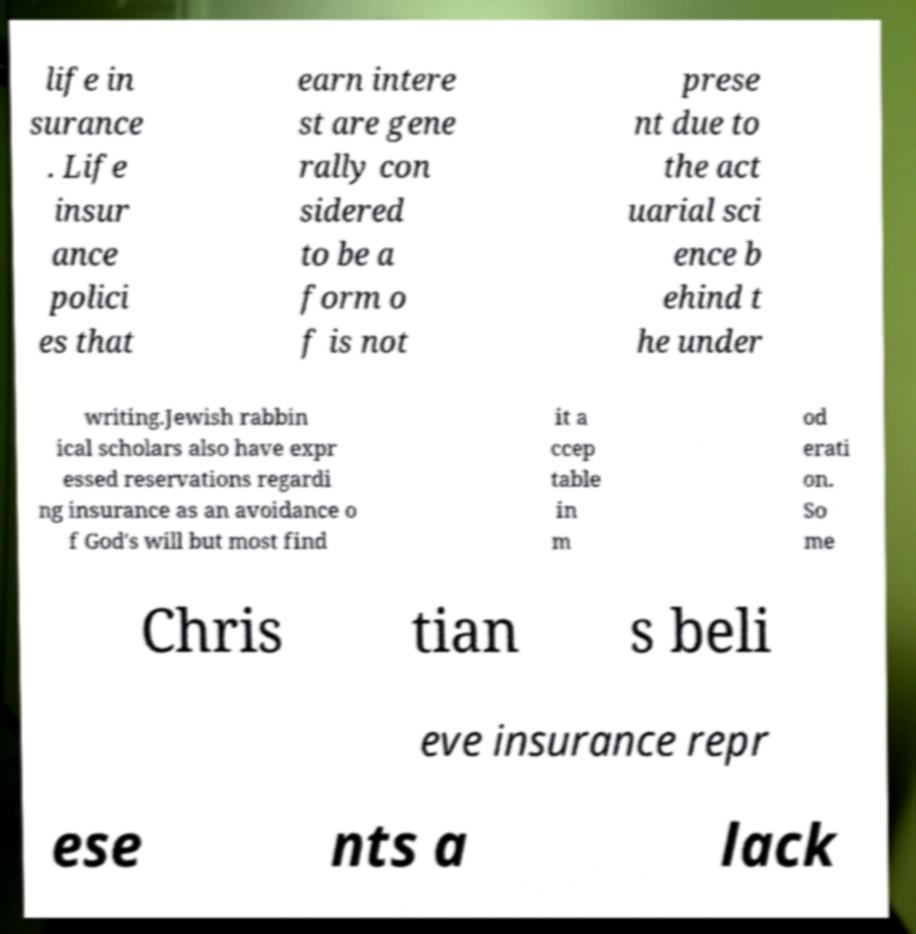Could you extract and type out the text from this image? life in surance . Life insur ance polici es that earn intere st are gene rally con sidered to be a form o f is not prese nt due to the act uarial sci ence b ehind t he under writing.Jewish rabbin ical scholars also have expr essed reservations regardi ng insurance as an avoidance o f God's will but most find it a ccep table in m od erati on. So me Chris tian s beli eve insurance repr ese nts a lack 